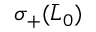Convert formula to latex. <formula><loc_0><loc_0><loc_500><loc_500>\sigma _ { + } ( \bar { L } _ { 0 } )</formula> 